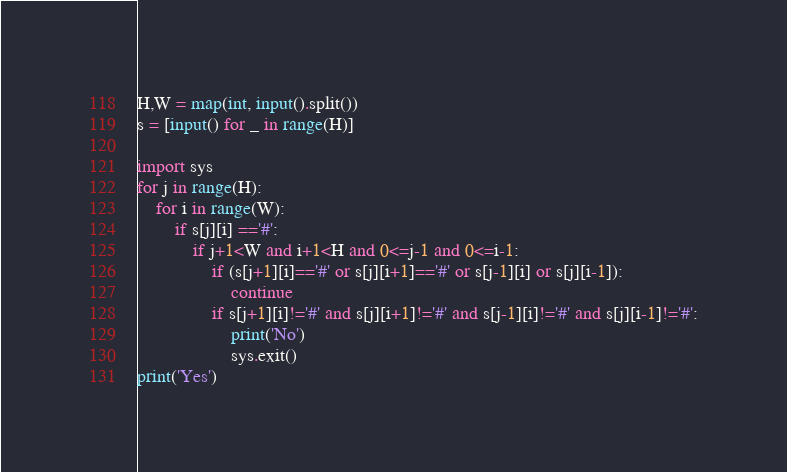<code> <loc_0><loc_0><loc_500><loc_500><_Python_>H,W = map(int, input().split())
s = [input() for _ in range(H)]

import sys
for j in range(H):
    for i in range(W):
        if s[j][i] =='#':
            if j+1<W and i+1<H and 0<=j-1 and 0<=i-1:
                if (s[j+1][i]=='#' or s[j][i+1]=='#' or s[j-1][i] or s[j][i-1]):
                    continue
                if s[j+1][i]!='#' and s[j][i+1]!='#' and s[j-1][i]!='#' and s[j][i-1]!='#':
                    print('No')
                    sys.exit()
print('Yes')
</code> 